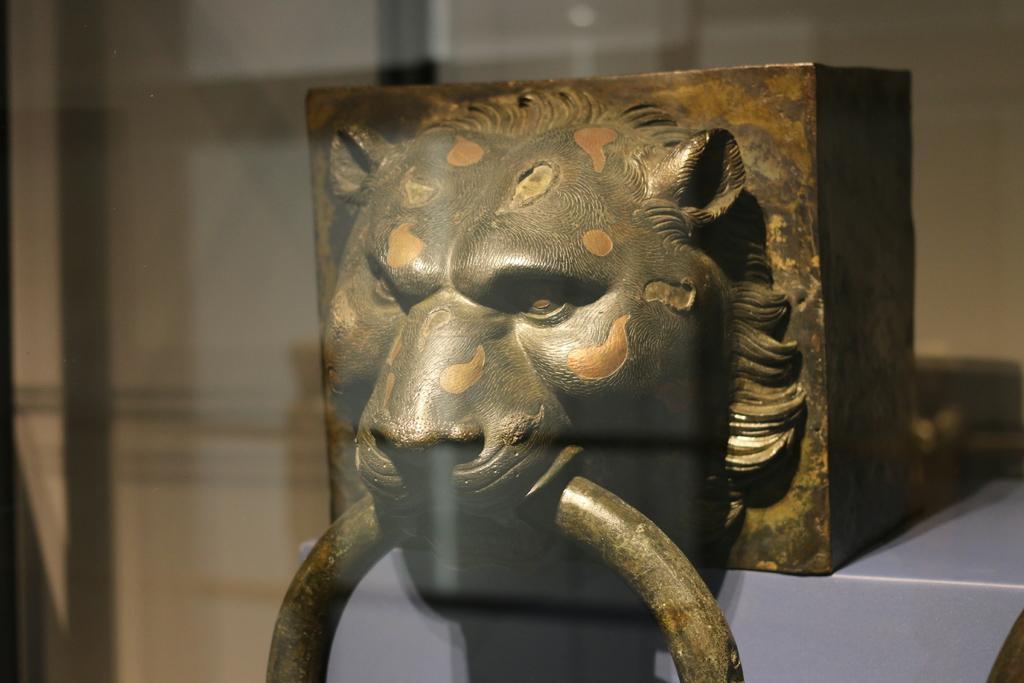Can you describe this image briefly? In this image I can see it looks like an idle. 